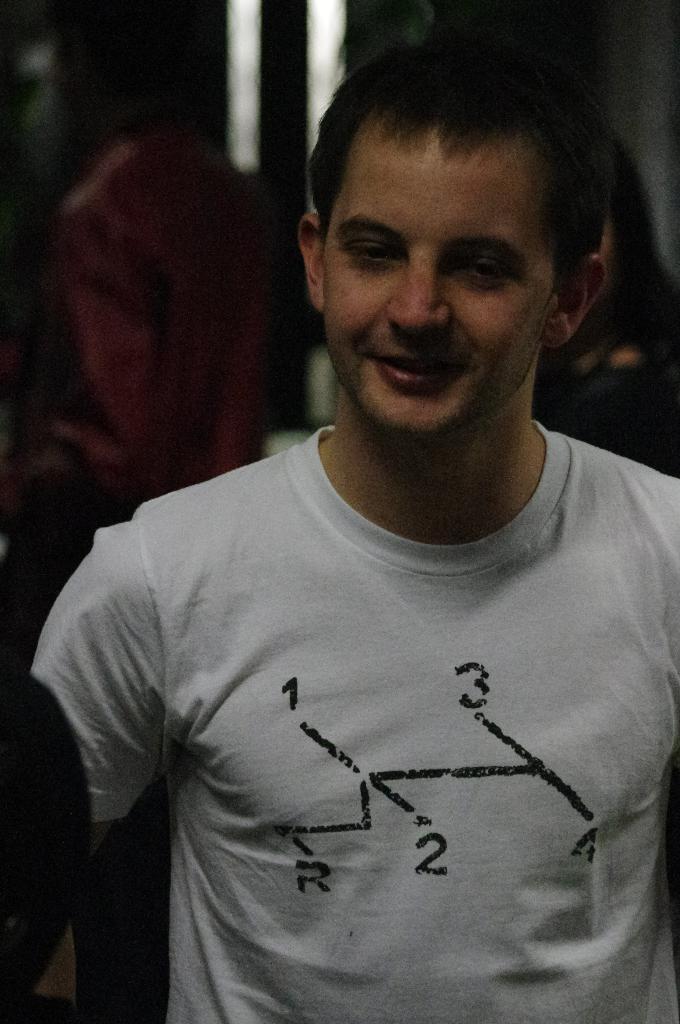How would you summarize this image in a sentence or two? In this image in the foreground there is a man wears white T-shirt and having black hair. 